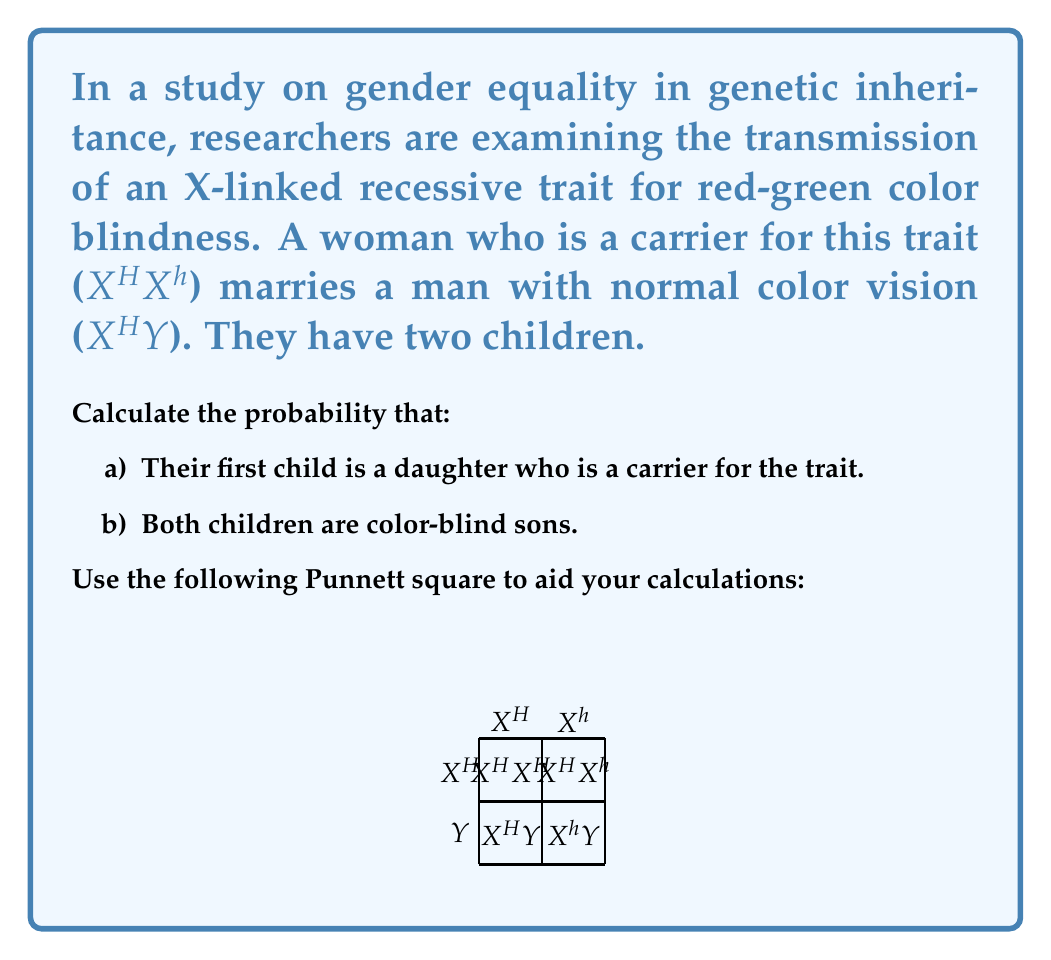Help me with this question. Let's approach this step-by-step:

1) First, let's understand the Punnett square:
   - The mother (carrier) has genotype X^HX^h
   - The father (normal vision) has genotype X^HY

2) From the Punnett square, we can see four possible outcomes:
   X^HX^H (normal daughter), X^HX^h (carrier daughter), X^HY (normal son), X^hY (color-blind son)

3) For part a), we need to calculate the probability of having a carrier daughter:
   - The probability of having a daughter is 1/2
   - The probability of the daughter being a carrier, given that it's a daughter, is 1/2
   - Therefore, the probability is: $\frac{1}{2} \times \frac{1}{2} = \frac{1}{4}$

4) For part b), we need to calculate the probability that both children are color-blind sons:
   - The probability of having a color-blind son in one birth is 1/4
   - We need this to happen twice independently
   - Therefore, the probability is: $\frac{1}{4} \times \frac{1}{4} = \frac{1}{16}$

This problem highlights how genetic traits can be passed down differently based on sex, which is an important consideration in discussions about genetic equity and gender in biology.
Answer: a) $\frac{1}{4}$
b) $\frac{1}{16}$ 